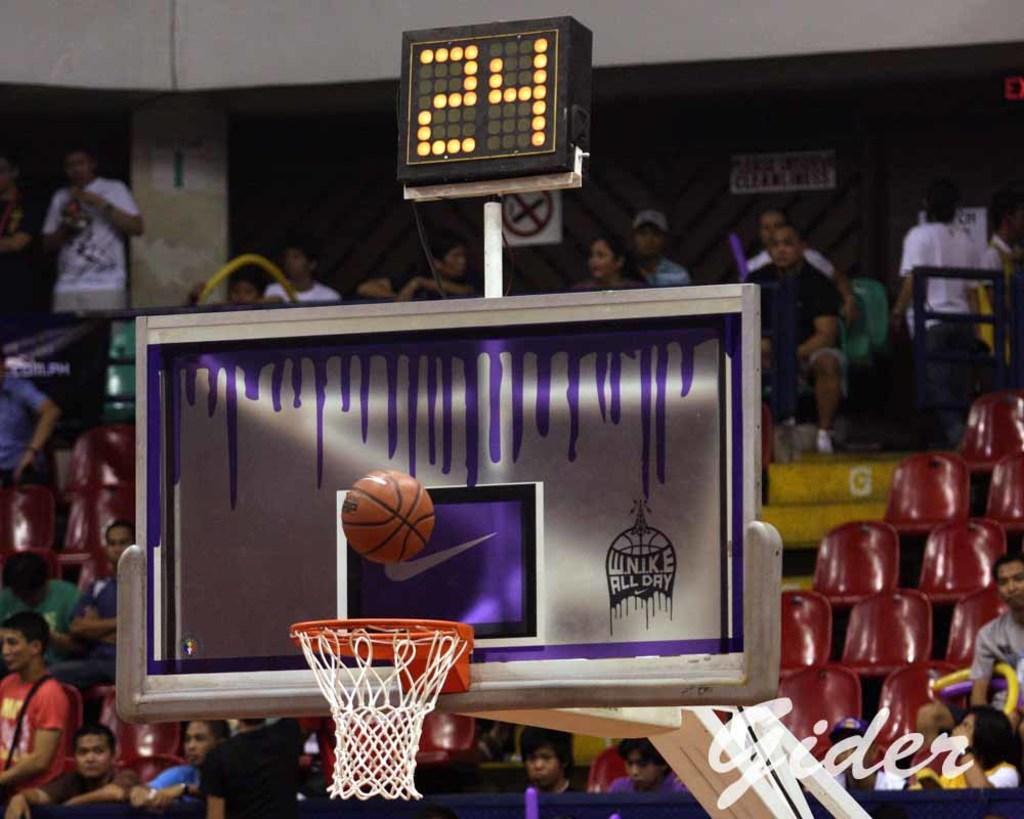Describe this image in one or two sentences. In this picture, we can see a few people, stairs, chairs, wall with posters, pillars, we can see basket ball goal court, with an object attached to it, we can see a display screen with numbers, and we can see a pole, some text in the bottom right side of the picture. 